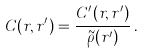<formula> <loc_0><loc_0><loc_500><loc_500>C ( r , r ^ { \prime } ) = \frac { C ^ { \prime } ( r , r ^ { \prime } ) } { \tilde { \rho } ( r ^ { \prime } ) } \, .</formula> 